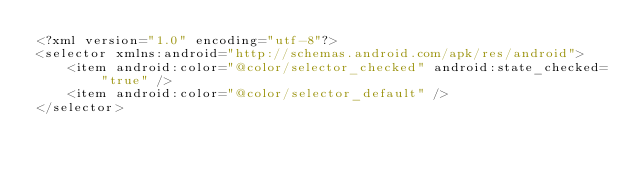<code> <loc_0><loc_0><loc_500><loc_500><_XML_><?xml version="1.0" encoding="utf-8"?>
<selector xmlns:android="http://schemas.android.com/apk/res/android">
    <item android:color="@color/selector_checked" android:state_checked="true" />
    <item android:color="@color/selector_default" />
</selector></code> 